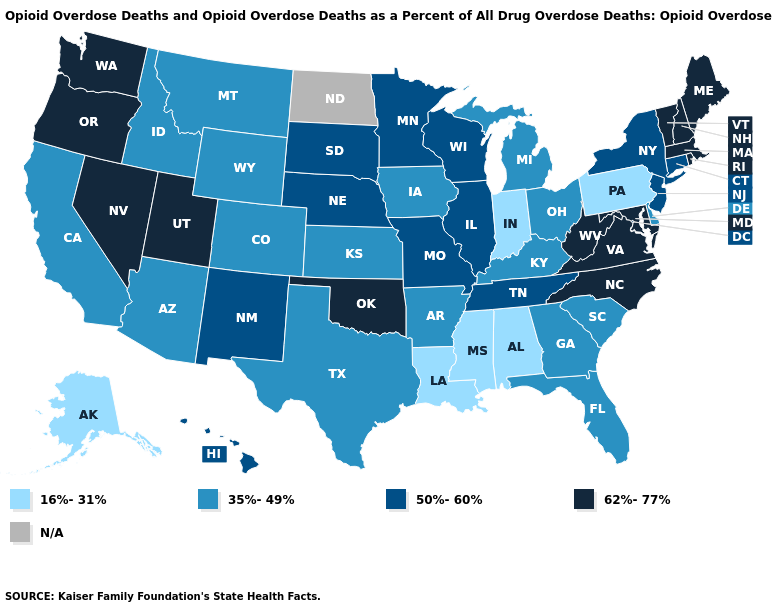Name the states that have a value in the range N/A?
Keep it brief. North Dakota. What is the value of Mississippi?
Write a very short answer. 16%-31%. Among the states that border Ohio , which have the lowest value?
Quick response, please. Indiana, Pennsylvania. Is the legend a continuous bar?
Answer briefly. No. Among the states that border Georgia , which have the highest value?
Give a very brief answer. North Carolina. What is the value of Alabama?
Concise answer only. 16%-31%. What is the lowest value in the USA?
Quick response, please. 16%-31%. What is the lowest value in the USA?
Concise answer only. 16%-31%. What is the value of New Hampshire?
Quick response, please. 62%-77%. What is the value of Wyoming?
Be succinct. 35%-49%. What is the highest value in states that border Nevada?
Keep it brief. 62%-77%. How many symbols are there in the legend?
Write a very short answer. 5. Does the map have missing data?
Write a very short answer. Yes. What is the value of Missouri?
Short answer required. 50%-60%. 